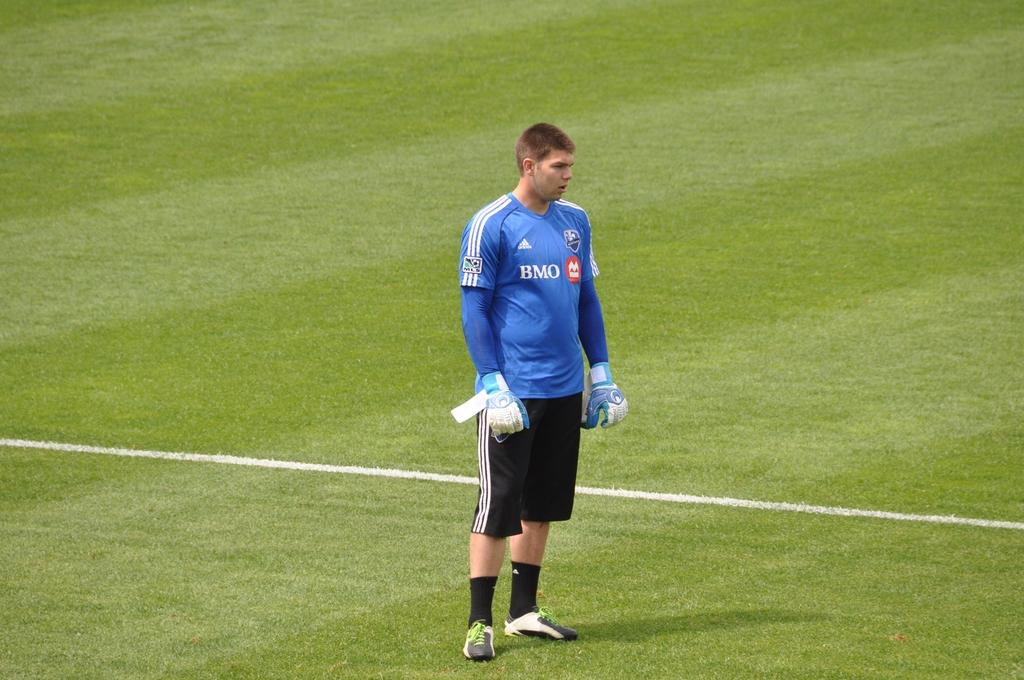Provide a one-sentence caption for the provided image. A player wearing a BMO shirt stands on a grass field. 